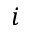Convert formula to latex. <formula><loc_0><loc_0><loc_500><loc_500>i</formula> 